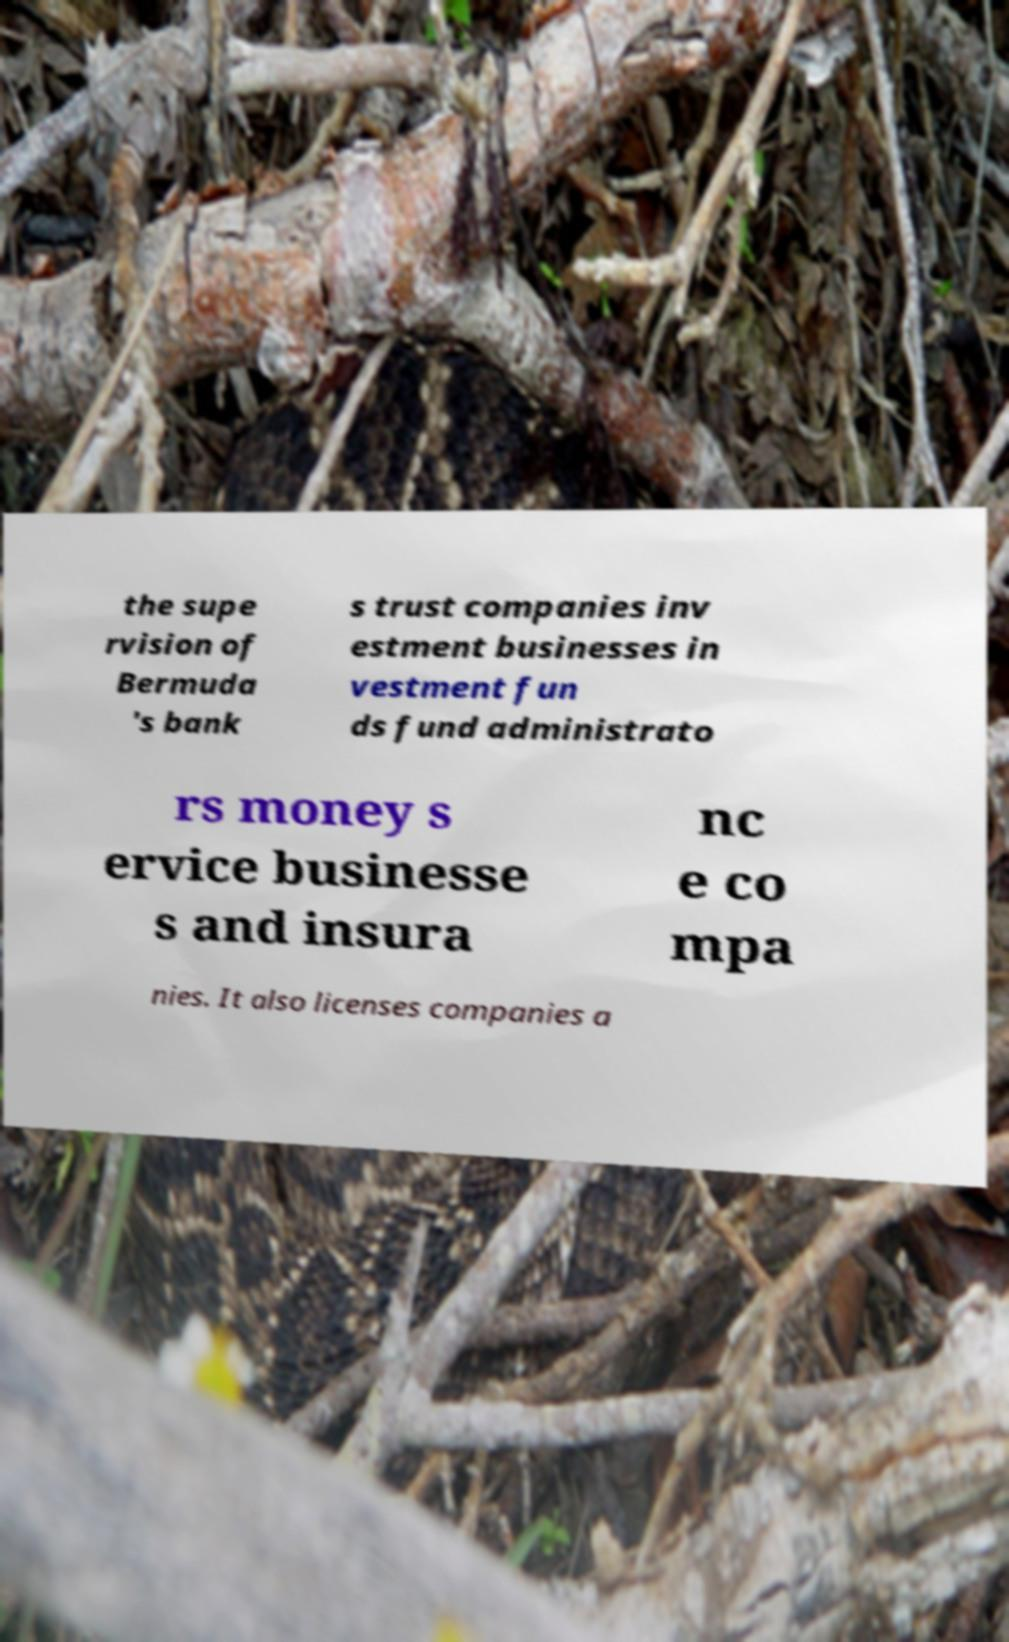Please read and relay the text visible in this image. What does it say? the supe rvision of Bermuda 's bank s trust companies inv estment businesses in vestment fun ds fund administrato rs money s ervice businesse s and insura nc e co mpa nies. It also licenses companies a 